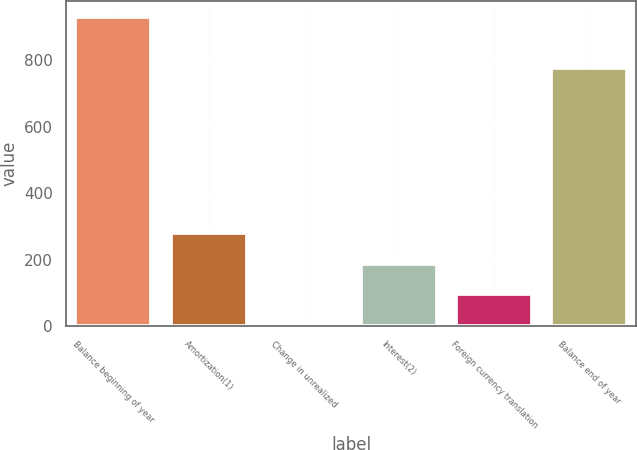<chart> <loc_0><loc_0><loc_500><loc_500><bar_chart><fcel>Balance beginning of year<fcel>Amortization(1)<fcel>Change in unrealized<fcel>Interest(2)<fcel>Foreign currency translation<fcel>Balance end of year<nl><fcel>930<fcel>281.1<fcel>3<fcel>188.4<fcel>95.7<fcel>776<nl></chart> 